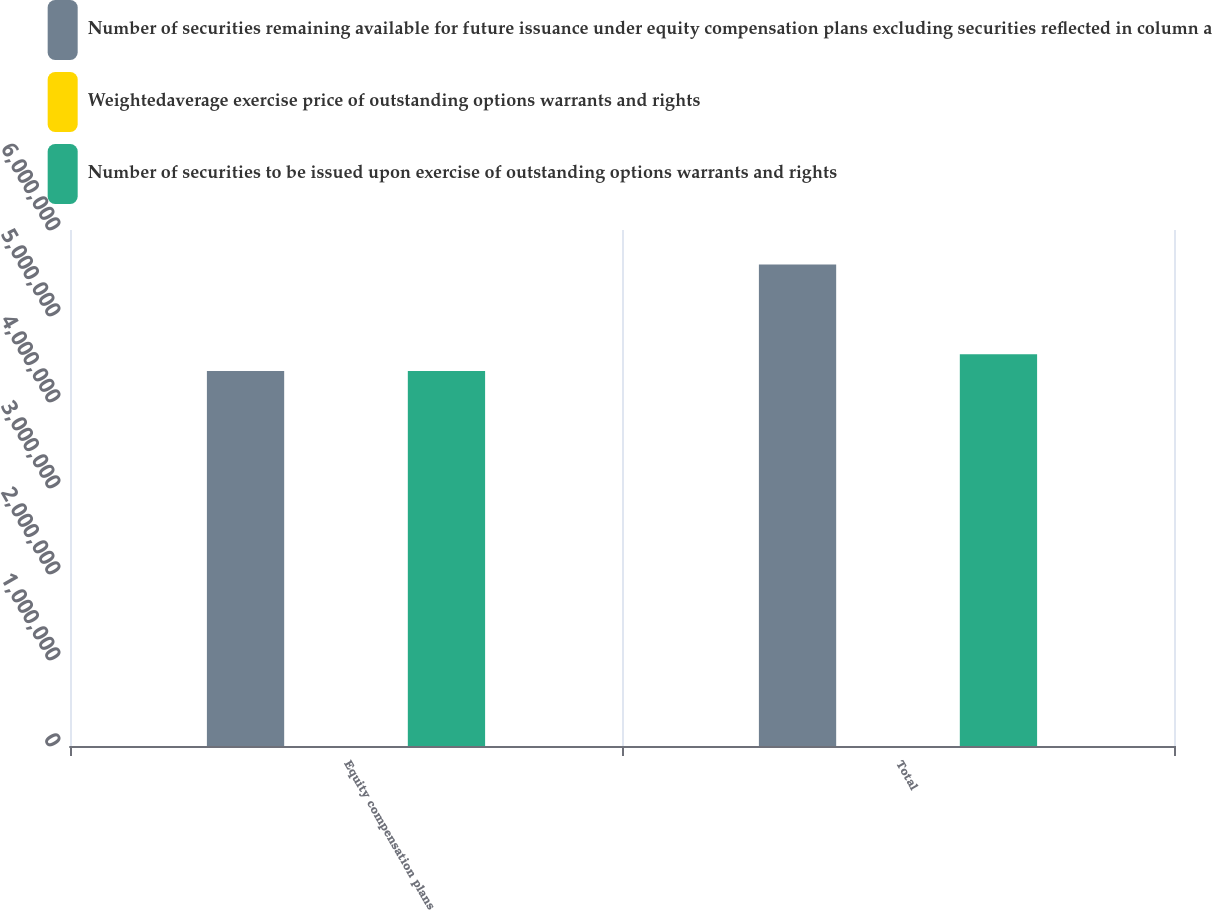<chart> <loc_0><loc_0><loc_500><loc_500><stacked_bar_chart><ecel><fcel>Equity compensation plans<fcel>Total<nl><fcel>Number of securities remaining available for future issuance under equity compensation plans excluding securities reflected in column a<fcel>4.36184e+06<fcel>5.59987e+06<nl><fcel>Weightedaverage exercise price of outstanding options warrants and rights<fcel>38.08<fcel>38.08<nl><fcel>Number of securities to be issued upon exercise of outstanding options warrants and rights<fcel>4.36184e+06<fcel>4.55498e+06<nl></chart> 